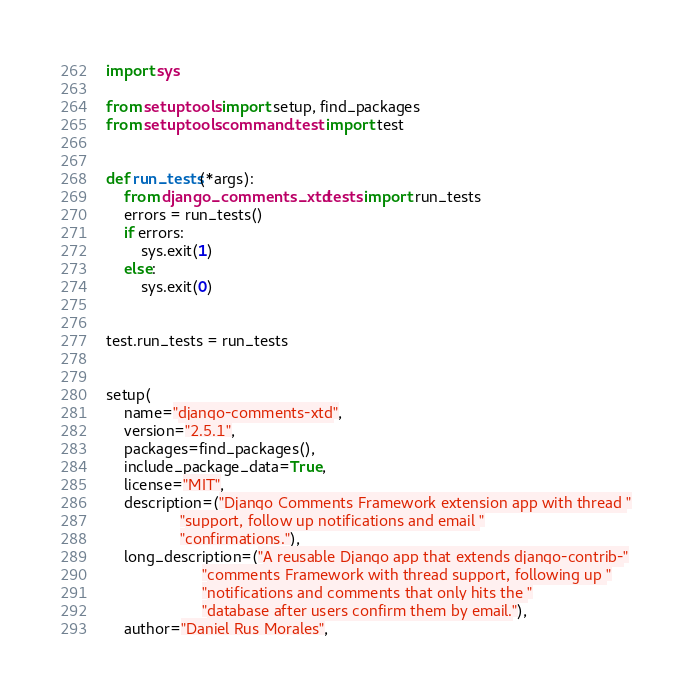Convert code to text. <code><loc_0><loc_0><loc_500><loc_500><_Python_>import sys

from setuptools import setup, find_packages
from setuptools.command.test import test


def run_tests(*args):
    from django_comments_xtd.tests import run_tests
    errors = run_tests()
    if errors:
        sys.exit(1)
    else:
        sys.exit(0)


test.run_tests = run_tests


setup(
    name="django-comments-xtd",
    version="2.5.1",
    packages=find_packages(),
    include_package_data=True,
    license="MIT",
    description=("Django Comments Framework extension app with thread "
                 "support, follow up notifications and email "
                 "confirmations."),
    long_description=("A reusable Django app that extends django-contrib-"
                      "comments Framework with thread support, following up "
                      "notifications and comments that only hits the "
                      "database after users confirm them by email."),
    author="Daniel Rus Morales",</code> 